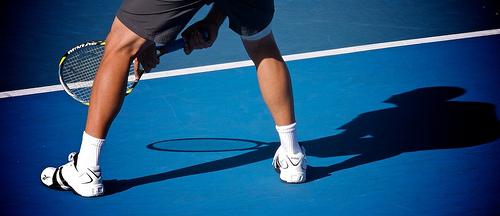Can you see the man's shadow?
Concise answer only. Yes. Is this lacrosse?
Quick response, please. No. The color of the court is green?
Write a very short answer. No. 